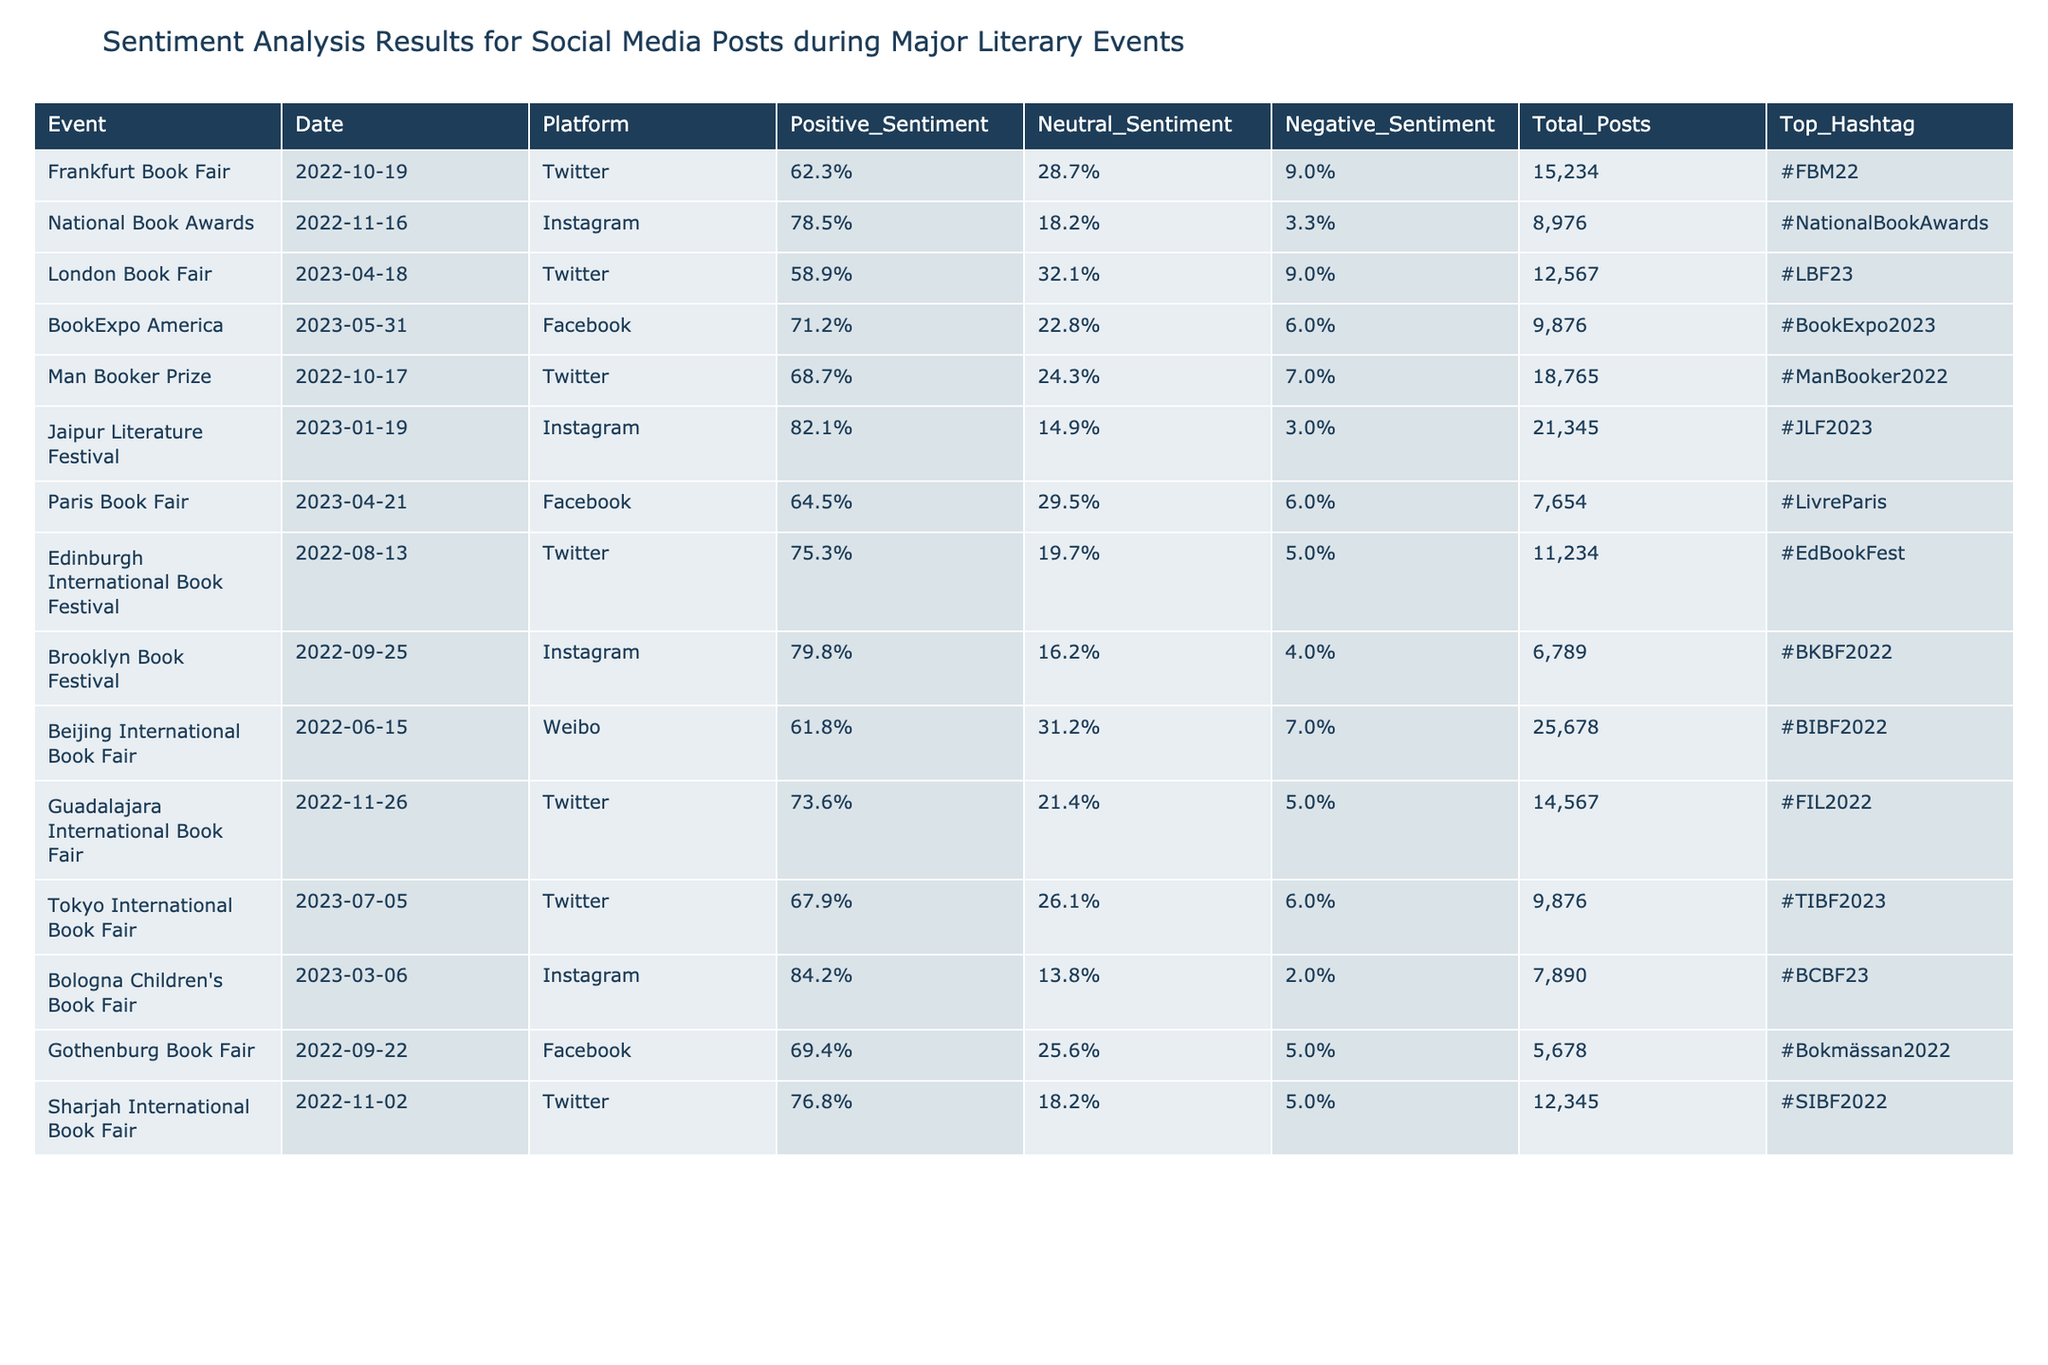What was the sentiment distribution for the Jaipur Literature Festival? The Jaipur Literature Festival had a Positive Sentiment of 82.1%, Neutral Sentiment of 14.9%, and Negative Sentiment of 3.0%.
Answer: Positive: 82.1%, Neutral: 14.9%, Negative: 3.0% Which literary event had the highest number of total posts? The Beijing International Book Fair had the highest number of total posts with 25,678 posts.
Answer: 25,678 What is the total percentage of negative sentiments across all events? Total up the Negative Sentiments for all events: (9.0 + 3.3 + 9.0 + 6.0 + 7.0 + 3.0 + 6.0 + 5.0 + 4.0 + 7.0 + 5.0 + 6.0 + 2.0 + 5.0) = 69.0% total negative sentiment for all events, then divide by the number of events (14) gives us an average of 69.0%/14 = 4.93% negative sentiment per event.
Answer: 4.93% Did the London Book Fair have a higher percentage of positive sentiment than the Frankfurt Book Fair? The London Book Fair had a Positive Sentiment of 58.9%, while the Frankfurt Book Fair had a Positive Sentiment of 62.3%. Since 58.9% is less than 62.3%, the statement is false.
Answer: No Which event had the lowest neutral sentiment percentage? The Bologna Children's Book Fair had the lowest neutral sentiment percentage at 13.8%.
Answer: 13.8% Calculate the average positive sentiment of all events held in 2022. Sum the Positive Sentiments of 2022: (62.3 + 78.5 + 68.7 + 75.3 + 79.8 + 61.8 + 73.6 + 76.8) = 496.0%. There are 8 events in 2022, thus the average is 496.0% / 8 = 62.0%.
Answer: 62.0% Among the events listed, did more than half have a positive sentiment over 70%? Count the events with positive sentiment over 70%: National Book Awards (78.5), Jaipur Literature Festival (82.1), BookExpo America (71.2), Brooklyn Book Festival (79.8), Sharjah International Book Fair (76.8), Bologna Children's Book Fair (84.2). That's 6 out of 14 events. Since half of 14 is 7, then less than half had positive sentiment over 70%.
Answer: No What was the percentage difference in positive sentiment between the National Book Awards and the Edinburgh International Book Festival? Positive Sentiment for National Book Awards is 78.5% and for Edinburgh International Book Festival is 75.3%. The percentage difference is 78.5 - 75.3 = 3.2%.
Answer: 3.2% 